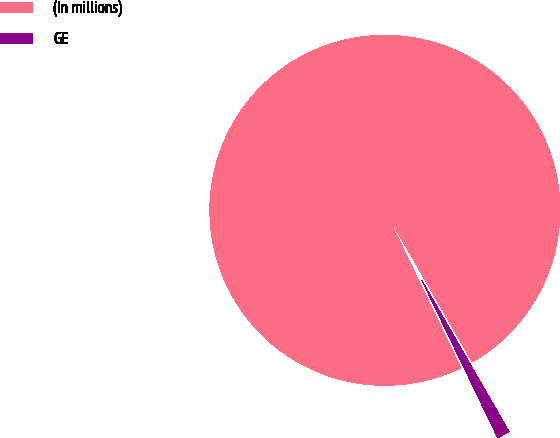Convert chart to OTSL. <chart><loc_0><loc_0><loc_500><loc_500><pie_chart><fcel>(In millions)<fcel>GE<nl><fcel>98.82%<fcel>1.18%<nl></chart> 